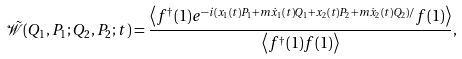<formula> <loc_0><loc_0><loc_500><loc_500>\mathcal { \tilde { W } } ( Q _ { 1 } , P _ { 1 } ; Q _ { 2 } , P _ { 2 } ; t ) = \frac { \left \langle f ^ { \dag } ( 1 ) e ^ { - i ( x _ { 1 } ( t ) P _ { 1 } + m \dot { x } _ { 1 } ( t ) Q _ { 1 } + x _ { 2 } ( t ) P _ { 2 } + m \dot { x } _ { 2 } ( t ) Q _ { 2 } ) / } f ( 1 ) \right \rangle } { \left \langle f ^ { \dag } ( 1 ) f ( 1 ) \right \rangle } ,</formula> 